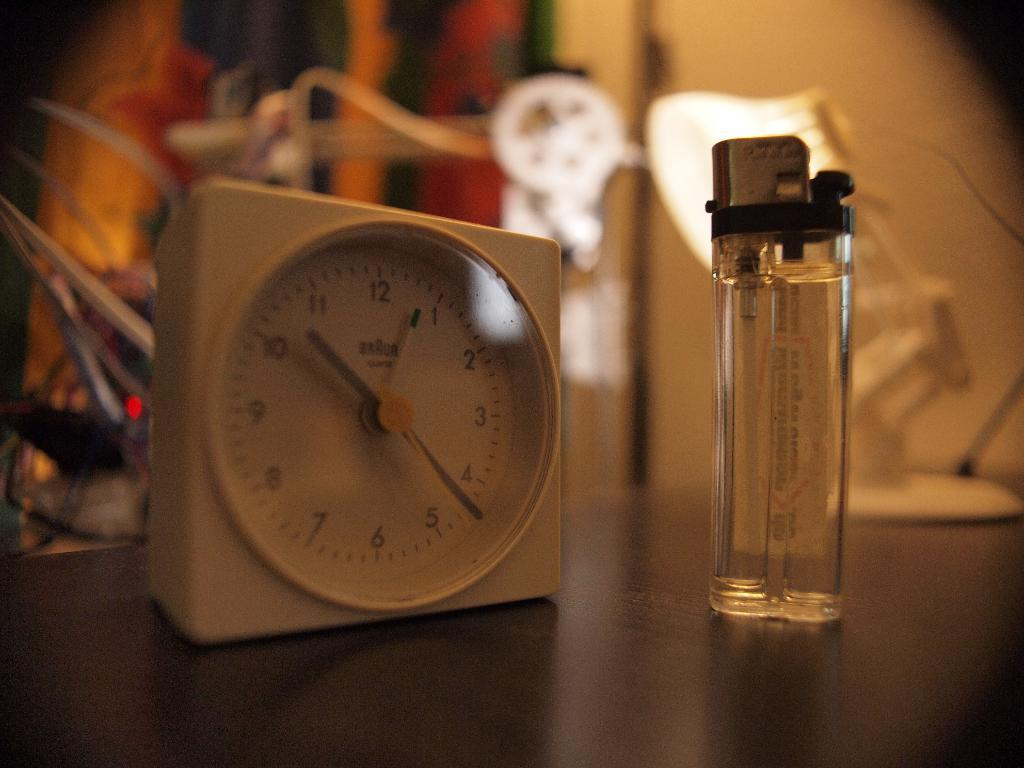Provide a one-sentence caption for the provided image. A lighter stands next to a Braun clock that shows the time as 10:22. 